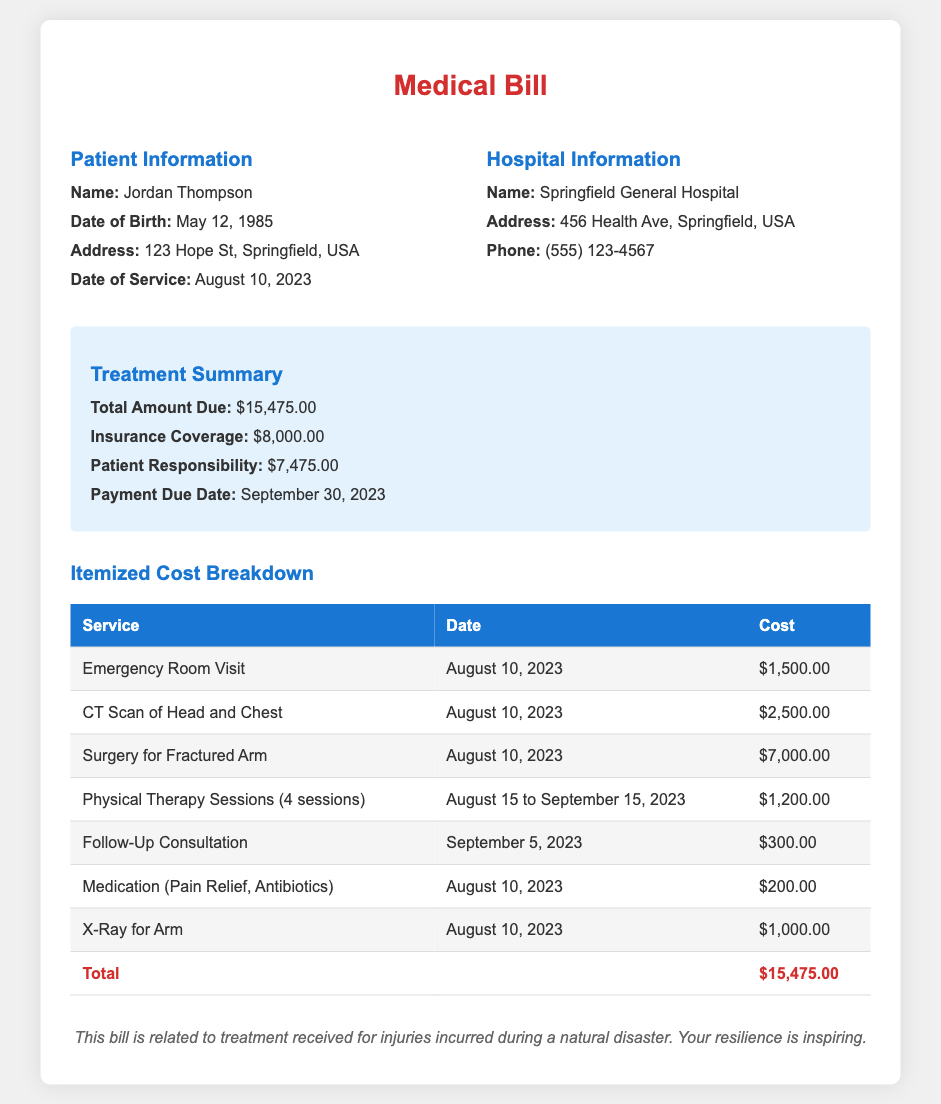What is the patient's name? The patient's name is clearly listed in the document.
Answer: Jordan Thompson What is the total amount due? The total amount due is specified in the summary section.
Answer: $15,475.00 When was the follow-up consultation? The date for the follow-up consultation is mentioned in the itemized breakdown.
Answer: September 5, 2023 How much did the CT scan of the head and chest cost? The cost of the CT scan is specified in the itemized cost breakdown.
Answer: $2,500.00 What is the patient's responsibility after insurance coverage? The document specifies what the patient is responsible for after insurance.
Answer: $7,475.00 What type of treatment was included for the fractured arm? The nature of the treatment related to the fractured arm is stated in one of the services.
Answer: Surgery How many physical therapy sessions were provided? The itemized breakdown lists the number of sessions included.
Answer: 4 sessions What hospital treated the patient? The hospital name is provided in the document.
Answer: Springfield General Hospital What was the date of service? The date of service is clearly mentioned in the patient information section.
Answer: August 10, 2023 